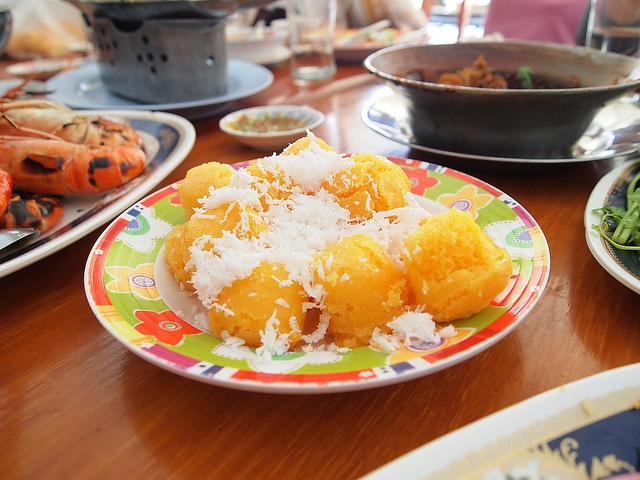Describe the objects in this image and their specific colors. I can see dining table in lightgray, maroon, black, and brown tones, cake in lightgray, orange, and tan tones, bowl in lightgray, black, gray, and darkgray tones, cup in lightgray, gray, and black tones, and cup in lightgray, darkgray, tan, and brown tones in this image. 